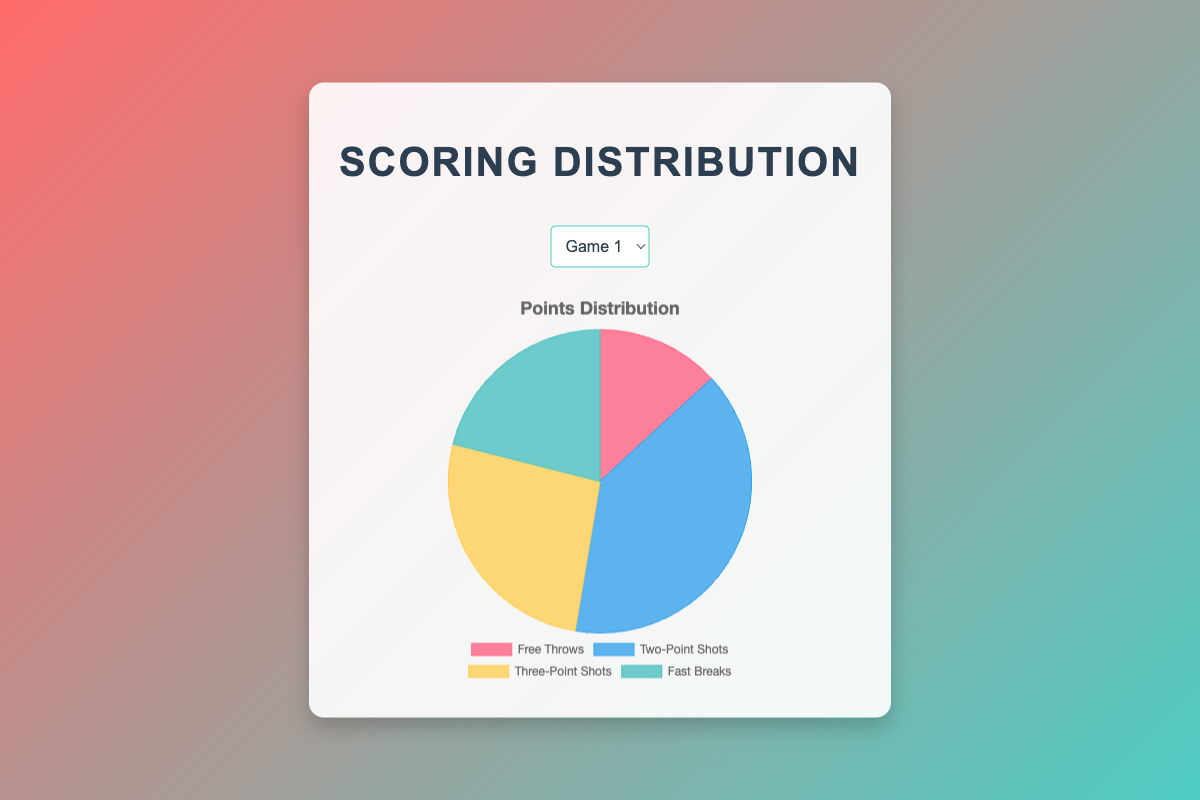Which category scored the most points in Game 1? By looking at the pie chart for Game 1, the "Two-Point Shots" category has the largest slice, indicating it scored the most points.
Answer: Two-Point Shots How many total points were scored in Game 2? Sum of all categories in the pie chart for Game 2: Free Throws (6) + Two-Point Shots (14) + Three-Point Shots (12) + Fast Breaks (7) = 6 + 14 + 12 + 7 = 39
Answer: 39 Which category has the smallest score in Game 3? By comparing the slices of the pie chart for Game 3, the "Free Throws" category has the smallest slice, indicating it has the smallest score.
Answer: Free Throws What is the difference in points between Two-Point Shots and Three-Point Shots in Game 4? From the pie charts we note: Two-Point Shots (16) - Three-Point Shots (11) = 5
Answer: 5 What portion of the total score in Game 1 is made up of Three-Point Shots? The total points in Game 1 are 38. The portion of Three-Point Shots is (10/38) which simplifies to approximately 26.32%.
Answer: Approximately 26.32% Which game had the highest number of Fast Break points? By comparing the Fast Break slices between all games, Game 3 has the highest Fast Break points with 10 points.
Answer: Game 3 Are the Fast Break points in Game 4 greater than or equal to those in Game 2? Fast Break points in Game 4 are 6 and in Game 2 are 7. 6 < 7, so Fast Break points in Game 4 are not greater than or equal to those in Game 2.
Answer: No If combining Free Throws and Fast Breaks, which game had the highest combined score for these categories? First calculate combined scores: Game 1 (5 + 8 = 13), Game 2 (6 + 7 = 13), Game 3 (8 + 10 = 18), Game 4 (7 + 6 = 13). Game 3 has the highest combined score with 18 points.
Answer: Game 3 